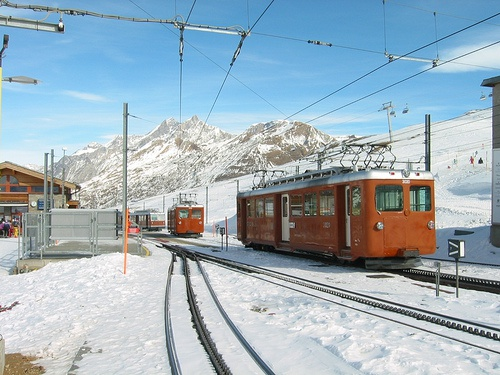Describe the objects in this image and their specific colors. I can see train in gray, maroon, brown, and black tones, train in gray, brown, lightgray, and darkgray tones, train in gray, darkgray, black, and lightgray tones, and people in gray, tan, and brown tones in this image. 